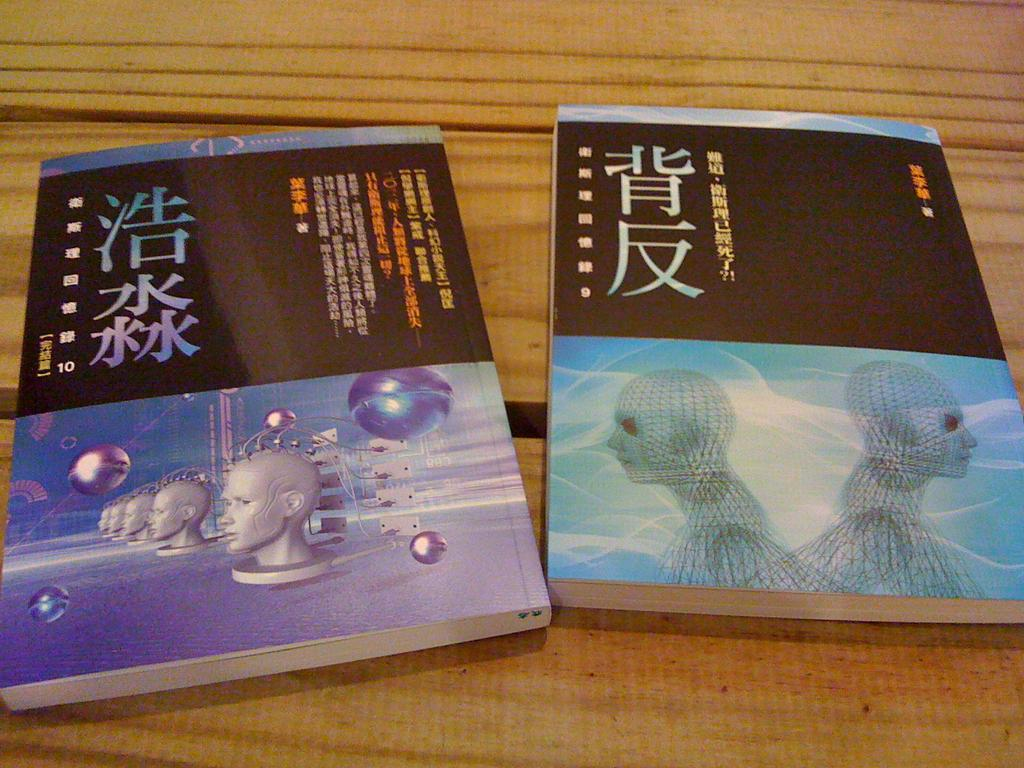How many books are present in the image? There are two books in the image. What type of surface are the books placed on? The books are on a wooden surface. What can be seen on the books? There is text visible on the books, and there are mannequin images on them. What type of crime is being committed by the mannequin in the image? There is no mannequin present in the image, nor is there any crime being committed. 